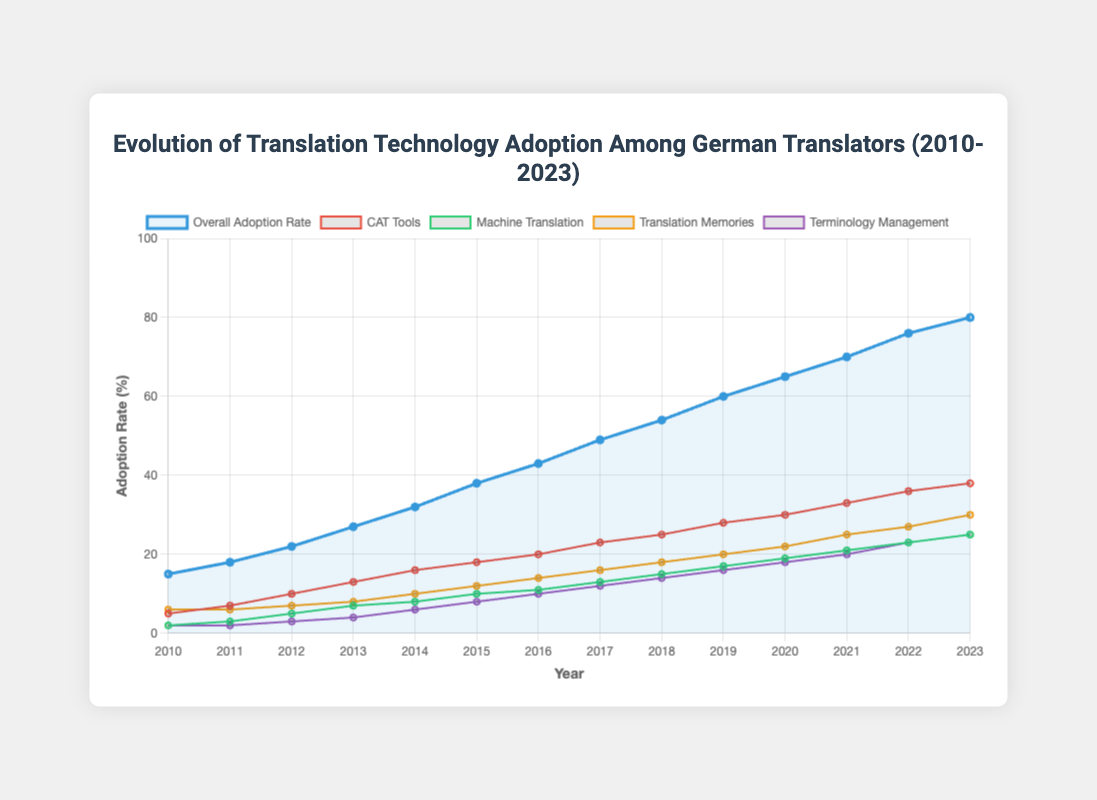What was the overall adoption rate of translation technologies in 2015? To find the overall adoption rate in 2015, look at the data point on the line labeled "Overall Adoption Rate" corresponding to the year 2015.
Answer: 38% How much did the adoption rate of CAT tools increase from 2010 to 2023? Find the adoption rate of CAT tools in 2010 and 2023, then subtract the 2010 value from the 2023 value. In 2010, the adoption rate was 5%, and in 2023, it was 38%. Thus, the increase is 38 - 5.
Answer: 33% Which year had the highest adoption rate for Machine Translation? Look at the data points for the line labeled "Machine Translation" to find the highest point, which corresponds to the highest adoption rate.
Answer: 2023 Between 2014 and 2016, which technology had the most significant increase in adoption rate? Calculate the difference in adoption rates for each technology between 2014 and 2016. 
CAT Tools: 20 - 16 = 4
Machine Translation: 11 - 8 = 3
Translation Memories: 14 - 10 = 4
Terminology Management: 10 - 6 = 4
Multiple technologies share the most significant increase.
Answer: CAT Tools, Translation Memories, and Terminology Management What is the overall trend of the adoption rate for Terminology Management from 2010 to 2023? Observe the line labeled "Terminology Management" to notice whether the trend is increasing, decreasing, or stable. The trend continually increases from 2% in 2010 to 25% in 2023.
Answer: Increasing In which year was the gap between CAT tools and Machine Translation adoption rates the largest, and what was the gap? Calculate the difference between the adoption rates of CAT tools and Machine Translation for each year. The year with the largest gap is the year with the highest difference.
For example, in 2010, the gap is 5 - 2 = 3, and in 2023, the gap is 38 - 25 = 13.
Answer: 2023, 13% How did the overall adoption rate change between 2011 and 2018? Determine the adoption rate for 2011 and 2018 and find the difference. The adoption rate in 2011 was 18%, and in 2018, it was 54%. 54 - 18 = 36.
Answer: Increased by 36% Which technology had the smallest increase in adoption rate over the given years? Evaluate the increase in adoption rates for each technology from 2010 to 2023. 
CAT Tools: 38 - 5 = 33
Machine Translation: 25 - 2 = 23
Translation Memories: 30 - 6 = 24
Terminology Management: 25 - 2 = 23
Machine Translation and Terminology Management share the smallest increase.
Answer: Machine Translation and Terminology Management Is there any technology whose adoption rate was the same in multiple consecutive years? Check each technology's adoption rates year by year. For example, Machine Translation and Terminology Management had the same rate from 2010 to 2011.
Answer: Yes, Machine Translation and Terminology Management from 2010 to 2011 